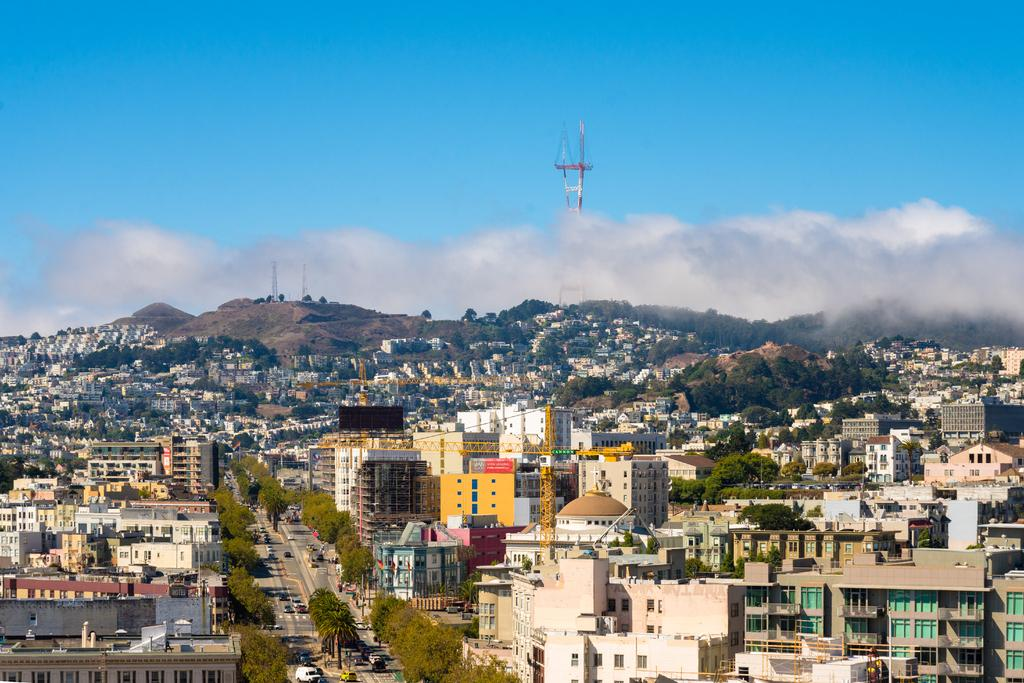What type of structures can be seen in the image? There are buildings in the image. What other natural elements are present in the image? There are trees in the image. Are there any construction-related objects visible in the image? Yes, there are cranes in the image. What can be seen on the road in the image? There are vehicles on the road in the image. What is the tallest structure visible in the image? There is a tower visible behind the buildings in the image. What type of landscape can be seen in the background of the image? There are hills in the background of the image. How would you describe the weather condition in the image? The sky is cloudy in the image. What type of ray is emitting light from the top of the tower in the image? There is no ray emitting light from the top of the tower in the image. What smell can be detected from the image? The image is visual, and smells cannot be detected from it. 